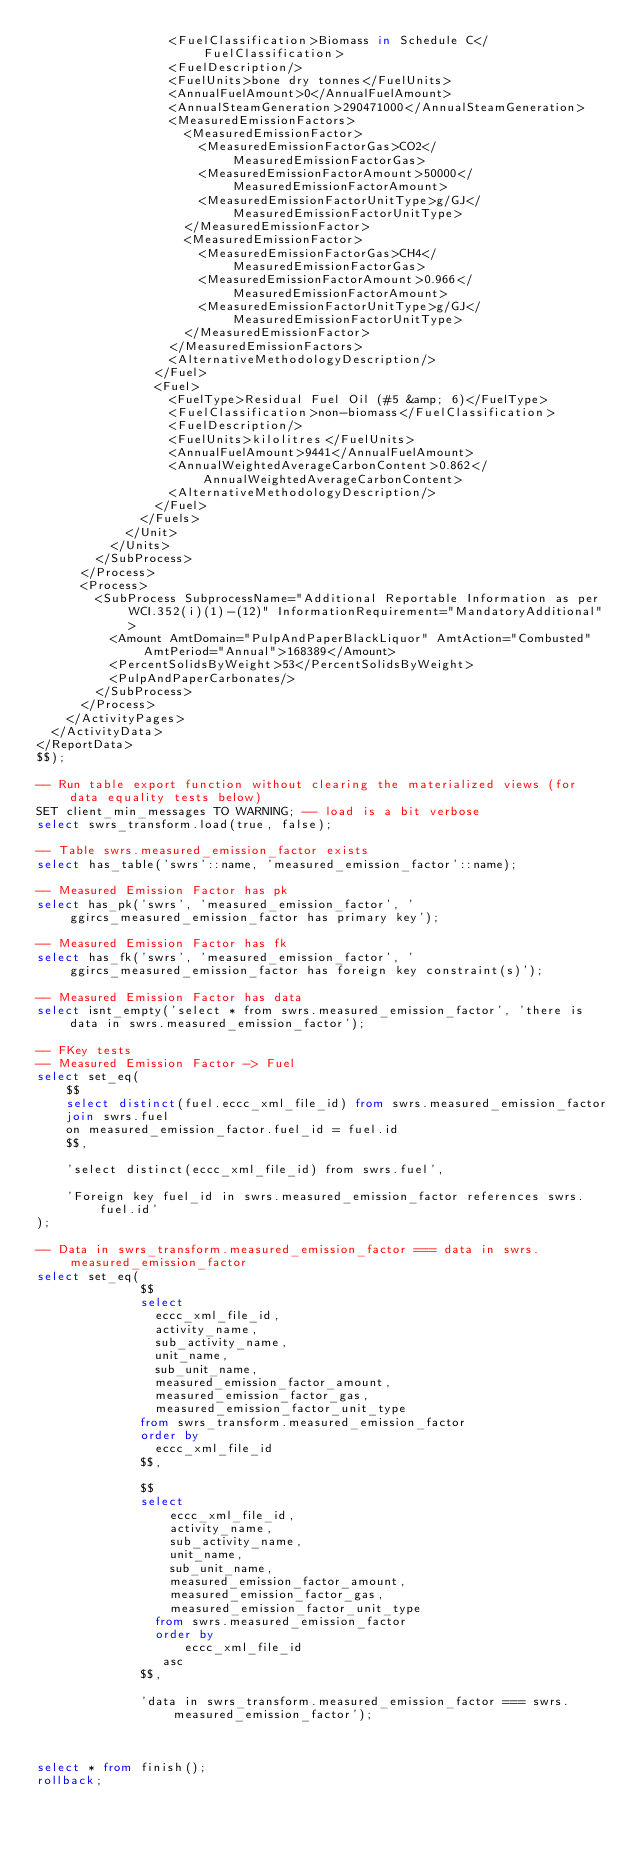<code> <loc_0><loc_0><loc_500><loc_500><_SQL_>                  <FuelClassification>Biomass in Schedule C</FuelClassification>
                  <FuelDescription/>
                  <FuelUnits>bone dry tonnes</FuelUnits>
                  <AnnualFuelAmount>0</AnnualFuelAmount>
                  <AnnualSteamGeneration>290471000</AnnualSteamGeneration>
                  <MeasuredEmissionFactors>
                    <MeasuredEmissionFactor>
                      <MeasuredEmissionFactorGas>CO2</MeasuredEmissionFactorGas>
                      <MeasuredEmissionFactorAmount>50000</MeasuredEmissionFactorAmount>
                      <MeasuredEmissionFactorUnitType>g/GJ</MeasuredEmissionFactorUnitType>
                    </MeasuredEmissionFactor>
                    <MeasuredEmissionFactor>
                      <MeasuredEmissionFactorGas>CH4</MeasuredEmissionFactorGas>
                      <MeasuredEmissionFactorAmount>0.966</MeasuredEmissionFactorAmount>
                      <MeasuredEmissionFactorUnitType>g/GJ</MeasuredEmissionFactorUnitType>
                    </MeasuredEmissionFactor>
                  </MeasuredEmissionFactors>
                  <AlternativeMethodologyDescription/>
                </Fuel>
                <Fuel>
                  <FuelType>Residual Fuel Oil (#5 &amp; 6)</FuelType>
                  <FuelClassification>non-biomass</FuelClassification>
                  <FuelDescription/>
                  <FuelUnits>kilolitres</FuelUnits>
                  <AnnualFuelAmount>9441</AnnualFuelAmount>
                  <AnnualWeightedAverageCarbonContent>0.862</AnnualWeightedAverageCarbonContent>
                  <AlternativeMethodologyDescription/>
                </Fuel>
              </Fuels>
            </Unit>
          </Units>
        </SubProcess>
      </Process>
      <Process>
        <SubProcess SubprocessName="Additional Reportable Information as per WCI.352(i)(1)-(12)" InformationRequirement="MandatoryAdditional">
          <Amount AmtDomain="PulpAndPaperBlackLiquor" AmtAction="Combusted" AmtPeriod="Annual">168389</Amount>
          <PercentSolidsByWeight>53</PercentSolidsByWeight>
          <PulpAndPaperCarbonates/>
        </SubProcess>
      </Process>
    </ActivityPages>
  </ActivityData>
</ReportData>
$$);

-- Run table export function without clearing the materialized views (for data equality tests below)
SET client_min_messages TO WARNING; -- load is a bit verbose
select swrs_transform.load(true, false);

-- Table swrs.measured_emission_factor exists
select has_table('swrs'::name, 'measured_emission_factor'::name);

-- Measured Emission Factor has pk
select has_pk('swrs', 'measured_emission_factor', 'ggircs_measured_emission_factor has primary key');

-- Measured Emission Factor has fk
select has_fk('swrs', 'measured_emission_factor', 'ggircs_measured_emission_factor has foreign key constraint(s)');

-- Measured Emission Factor has data
select isnt_empty('select * from swrs.measured_emission_factor', 'there is data in swrs.measured_emission_factor');

-- FKey tests
-- Measured Emission Factor -> Fuel
select set_eq(
    $$
    select distinct(fuel.eccc_xml_file_id) from swrs.measured_emission_factor
    join swrs.fuel
    on measured_emission_factor.fuel_id = fuel.id
    $$,

    'select distinct(eccc_xml_file_id) from swrs.fuel',

    'Foreign key fuel_id in swrs.measured_emission_factor references swrs.fuel.id'
);

-- Data in swrs_transform.measured_emission_factor === data in swrs.measured_emission_factor
select set_eq(
              $$
              select
                eccc_xml_file_id,
                activity_name,
                sub_activity_name,
                unit_name,
                sub_unit_name,
                measured_emission_factor_amount,
                measured_emission_factor_gas,
                measured_emission_factor_unit_type
              from swrs_transform.measured_emission_factor
              order by
                eccc_xml_file_id
              $$,

              $$
              select
                  eccc_xml_file_id,
                  activity_name,
                  sub_activity_name,
                  unit_name,
                  sub_unit_name,
                  measured_emission_factor_amount,
                  measured_emission_factor_gas,
                  measured_emission_factor_unit_type
                from swrs.measured_emission_factor
                order by
                    eccc_xml_file_id
                 asc
              $$,

              'data in swrs_transform.measured_emission_factor === swrs.measured_emission_factor');



select * from finish();
rollback;
</code> 